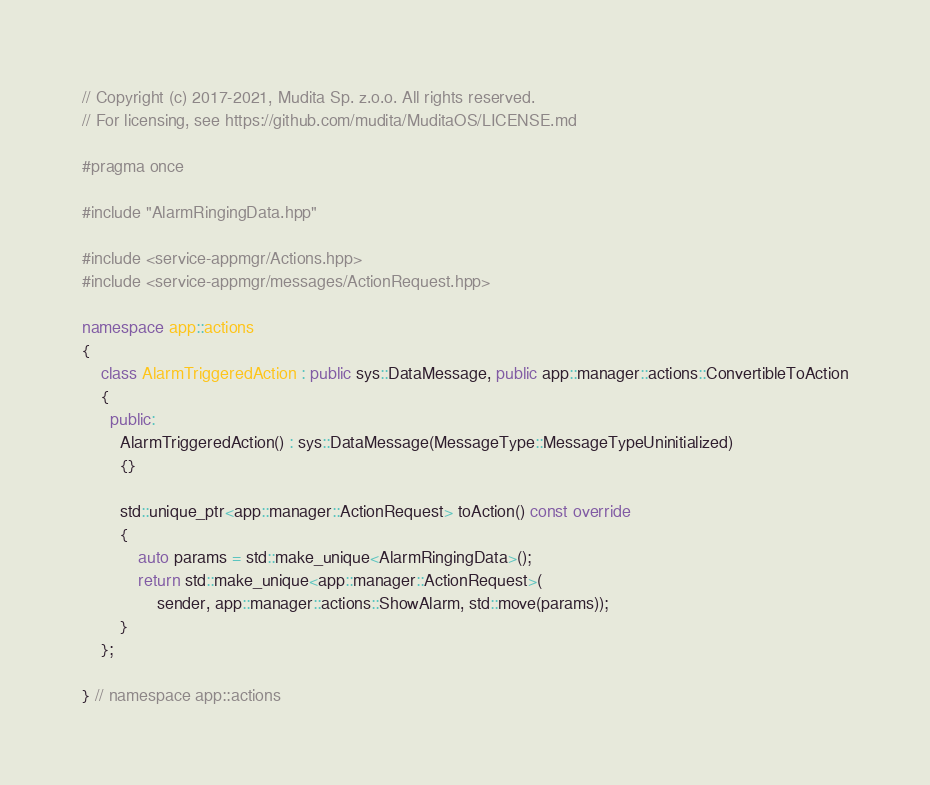<code> <loc_0><loc_0><loc_500><loc_500><_C++_>// Copyright (c) 2017-2021, Mudita Sp. z.o.o. All rights reserved.
// For licensing, see https://github.com/mudita/MuditaOS/LICENSE.md

#pragma once

#include "AlarmRingingData.hpp"

#include <service-appmgr/Actions.hpp>
#include <service-appmgr/messages/ActionRequest.hpp>

namespace app::actions
{
    class AlarmTriggeredAction : public sys::DataMessage, public app::manager::actions::ConvertibleToAction
    {
      public:
        AlarmTriggeredAction() : sys::DataMessage(MessageType::MessageTypeUninitialized)
        {}

        std::unique_ptr<app::manager::ActionRequest> toAction() const override
        {
            auto params = std::make_unique<AlarmRingingData>();
            return std::make_unique<app::manager::ActionRequest>(
                sender, app::manager::actions::ShowAlarm, std::move(params));
        }
    };

} // namespace app::actions
</code> 